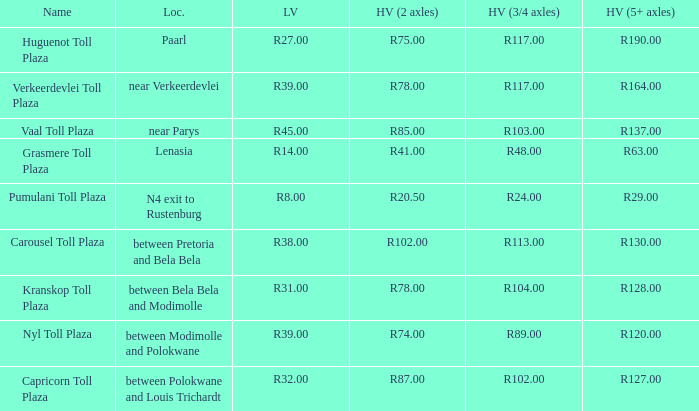What is the name of the plaza where the toll for heavy vehicles with 2 axles is r87.00? Capricorn Toll Plaza. 